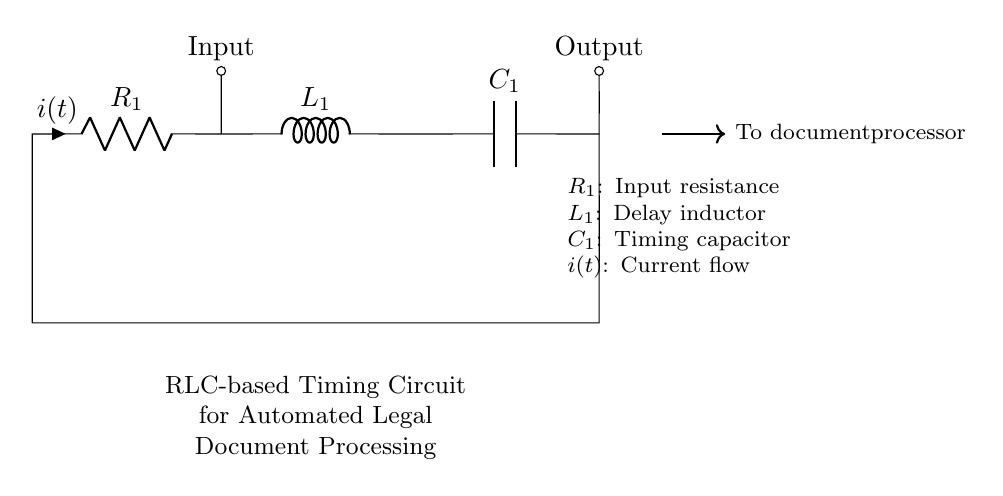What is the function of the resistor in this circuit? The resistor, indicated as R1, is responsible for limiting the current that flows through the circuit. This helps to prevent excessive current that could damage other components.
Answer: Limiting current What is the role of the inductor in this RLC circuit? The inductor, labeled as L1, introduces a delay in the current flow due to its property of opposing changes in current. This delay is essential for timing in the automated legal document processing system.
Answer: Introducing delay What is the value of the output current in this circuit? The output current is represented as i(t), which is the current flowing through the circuit at any given time. The exact value of i(t) would depend on the specific input and timing behavior of the circuit but is not provided.
Answer: i(t) How does the capacitor contribute to the timing function? The capacitor, C1, stores electrical energy and releases it at a specific rate, which is integral for creating timed intervals in the circuit. The charging and discharging behavior of the capacitor governs the timing characteristics of the circuit.
Answer: Storing energy What will happen if the resistance is increased? Increasing the resistance (R1) will reduce the current flowing through the circuit. This change can result in longer timing intervals and potentially alter the performance of the automated legal document processing system.
Answer: Reduce current Which component is responsible for the timing characteristics of the circuit? The timing characteristics primarily result from the interaction of the inductor (L1) and capacitor (C1), which together form an LC circuit. They work in tandem to determine how the energy oscillates, thus impacting timing.
Answer: Inductor and capacitor 